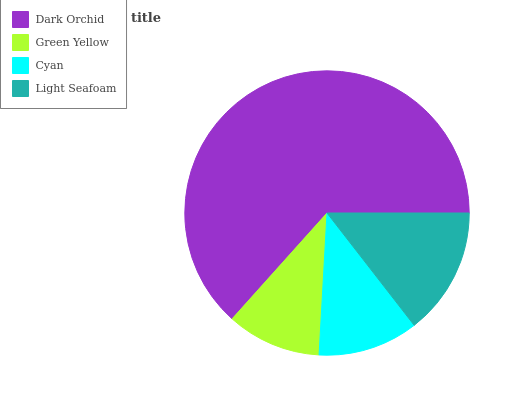Is Green Yellow the minimum?
Answer yes or no. Yes. Is Dark Orchid the maximum?
Answer yes or no. Yes. Is Cyan the minimum?
Answer yes or no. No. Is Cyan the maximum?
Answer yes or no. No. Is Cyan greater than Green Yellow?
Answer yes or no. Yes. Is Green Yellow less than Cyan?
Answer yes or no. Yes. Is Green Yellow greater than Cyan?
Answer yes or no. No. Is Cyan less than Green Yellow?
Answer yes or no. No. Is Light Seafoam the high median?
Answer yes or no. Yes. Is Cyan the low median?
Answer yes or no. Yes. Is Green Yellow the high median?
Answer yes or no. No. Is Light Seafoam the low median?
Answer yes or no. No. 